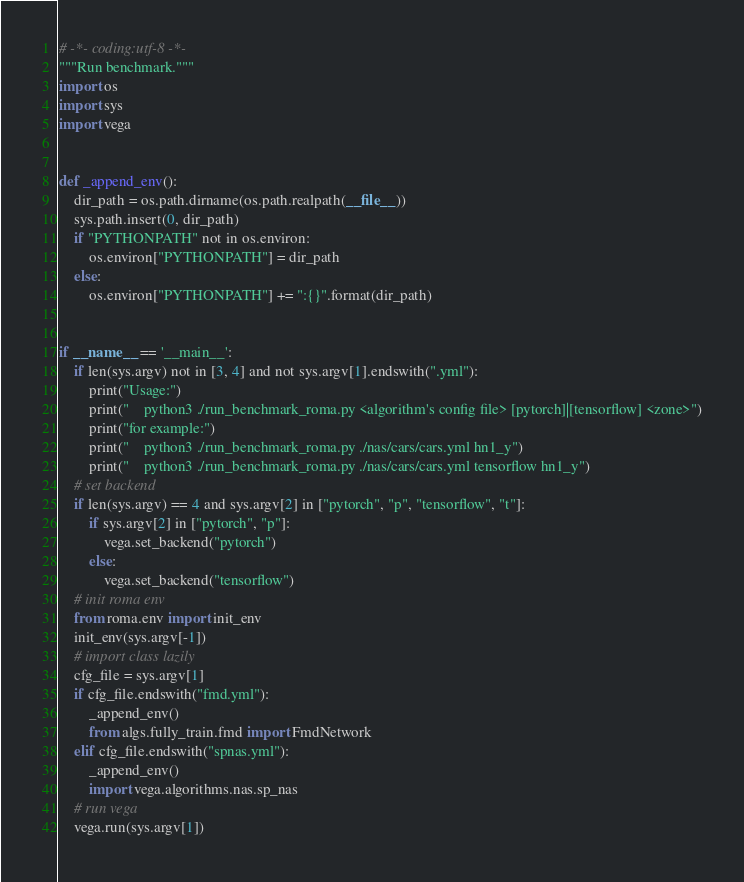Convert code to text. <code><loc_0><loc_0><loc_500><loc_500><_Python_># -*- coding:utf-8 -*-
"""Run benchmark."""
import os
import sys
import vega


def _append_env():
    dir_path = os.path.dirname(os.path.realpath(__file__))
    sys.path.insert(0, dir_path)
    if "PYTHONPATH" not in os.environ:
        os.environ["PYTHONPATH"] = dir_path
    else:
        os.environ["PYTHONPATH"] += ":{}".format(dir_path)


if __name__ == '__main__':
    if len(sys.argv) not in [3, 4] and not sys.argv[1].endswith(".yml"):
        print("Usage:")
        print("    python3 ./run_benchmark_roma.py <algorithm's config file> [pytorch]|[tensorflow] <zone>")
        print("for example:")
        print("    python3 ./run_benchmark_roma.py ./nas/cars/cars.yml hn1_y")
        print("    python3 ./run_benchmark_roma.py ./nas/cars/cars.yml tensorflow hn1_y")
    # set backend
    if len(sys.argv) == 4 and sys.argv[2] in ["pytorch", "p", "tensorflow", "t"]:
        if sys.argv[2] in ["pytorch", "p"]:
            vega.set_backend("pytorch")
        else:
            vega.set_backend("tensorflow")
    # init roma env
    from roma.env import init_env
    init_env(sys.argv[-1])
    # import class lazily
    cfg_file = sys.argv[1]
    if cfg_file.endswith("fmd.yml"):
        _append_env()
        from algs.fully_train.fmd import FmdNetwork
    elif cfg_file.endswith("spnas.yml"):
        _append_env()
        import vega.algorithms.nas.sp_nas
    # run vega
    vega.run(sys.argv[1])
</code> 